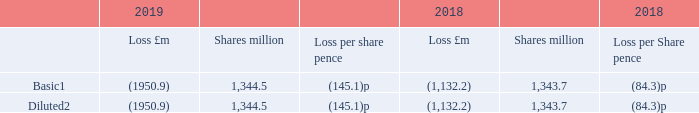12 Earnings per share
(a) Basic and diluted earnings per share
1 The weighted average number of shares used has been adjusted to remove shares held in the ESOP
2 Diluted shares include the impact of any dilutive convertible bonds, share options and share awards.
During 2017 the Group incurred a £49.4 million share related charge in relation to its Spanish development partner Eurofund’s future interests in the share capital of the intu Costa del Sol development company. The positive impact of this share related charge on equity attributable to owners of intu properties plc is a credit to retained earnings of £49.4 million. Subsequent to 31 December 2019, the Group has received the final ratifications required for full planning to become effective and therefore we expect the positive impact on retained earnings to reverse, once these arrangements are formally concluded.
What is the amount of share related charge incurred by the Group in 2019? £49.4 million. What do the diluted shares include? Impact of any dilutive convertible bonds, share options, share awards. What was the retained earnings in 2017? £49.4 million. In which year is there a greater loss (million)? Find the year with the higher loss value
Answer: 2019. In which year is there a greater loss per share (pence)? Find the year with the greater loss per share
Answer: 2019. In which year is there a greater number of shares? Find the year with the greater number of shares
Answer: 2019. 